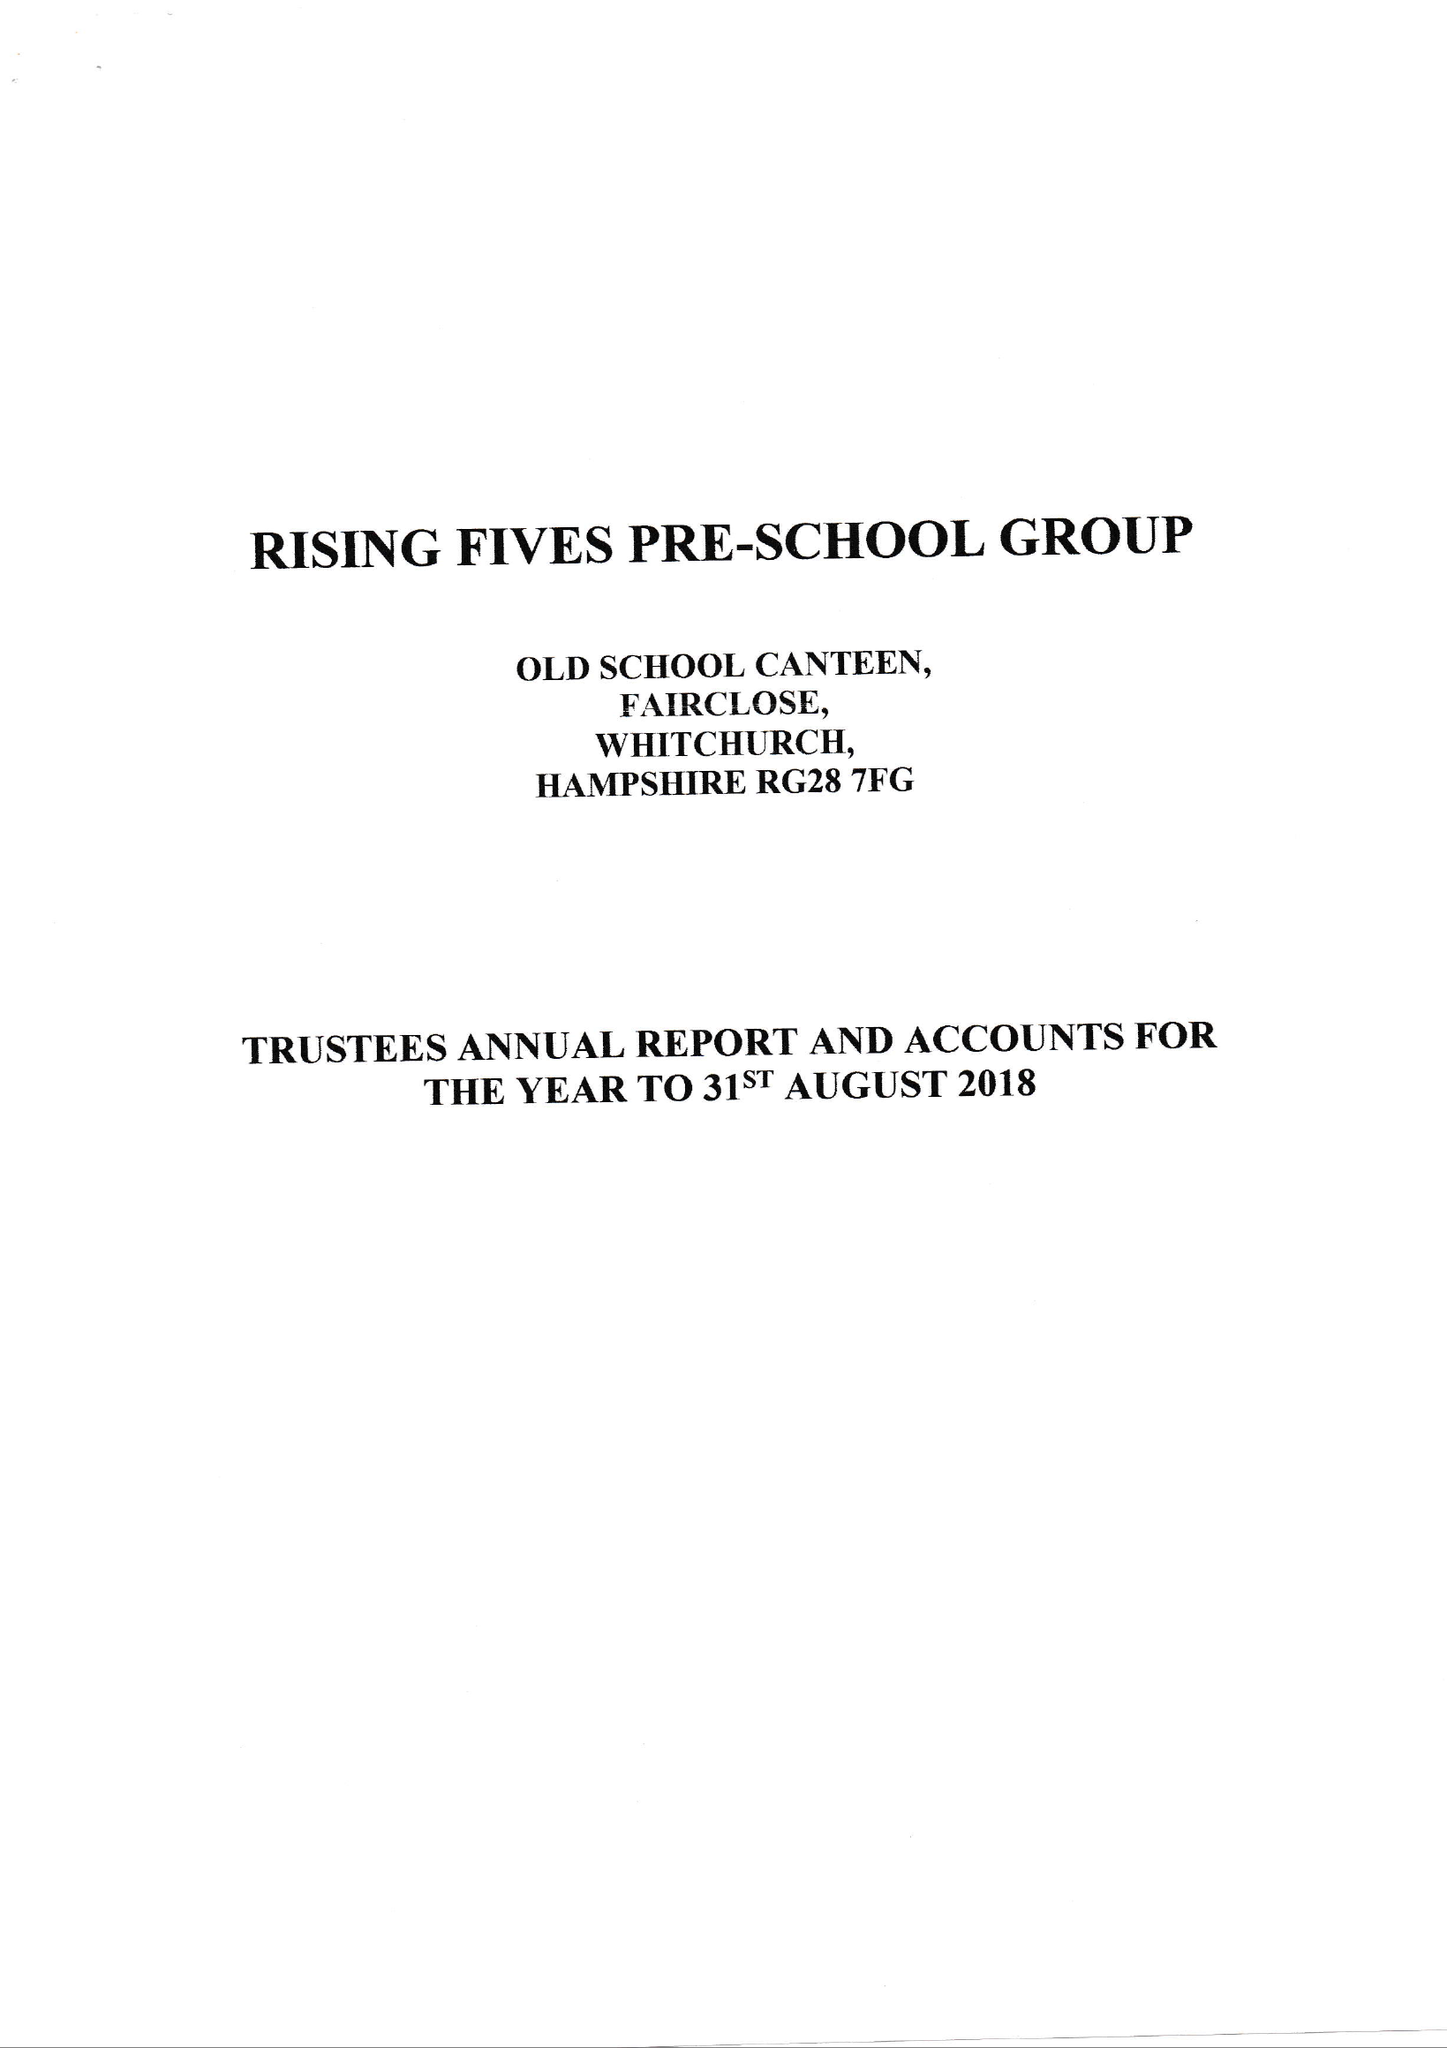What is the value for the charity_number?
Answer the question using a single word or phrase. 270065 